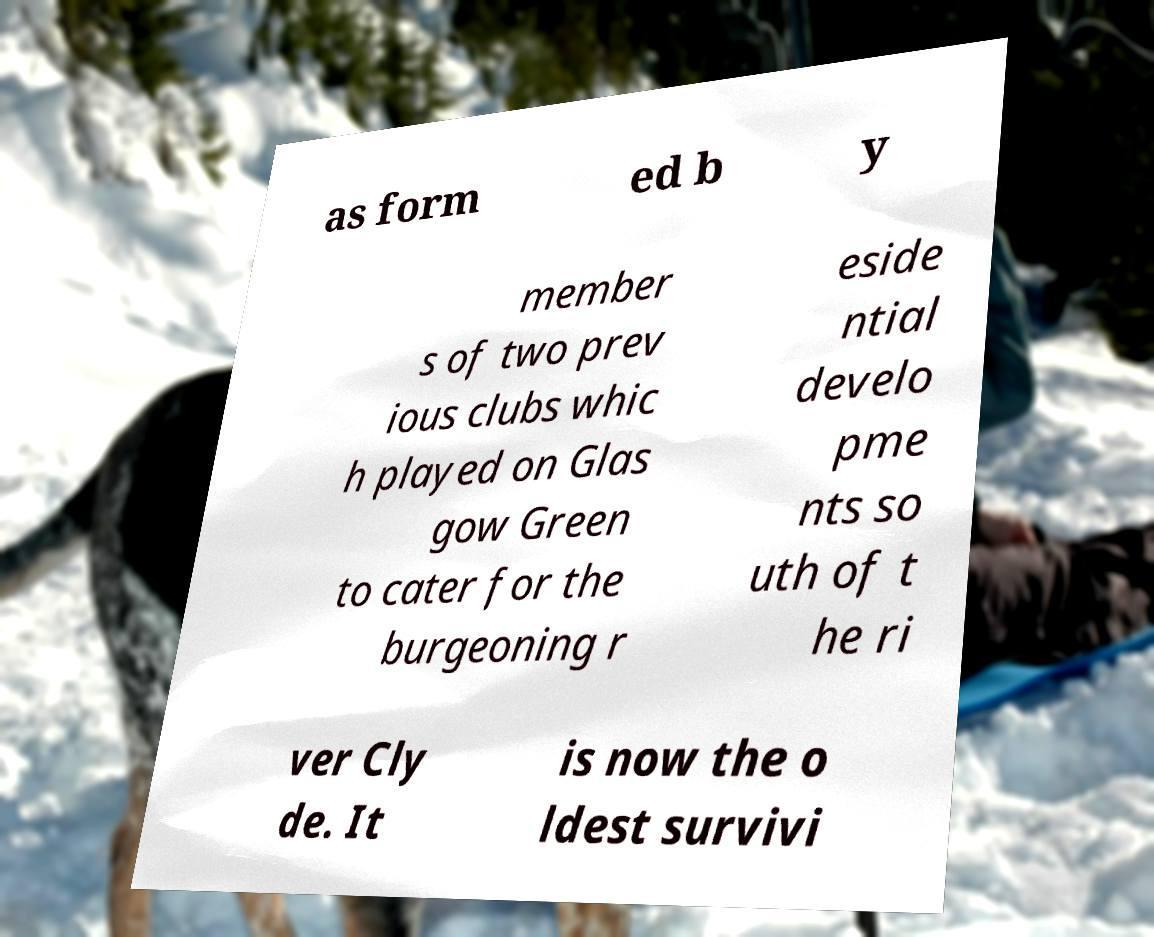For documentation purposes, I need the text within this image transcribed. Could you provide that? as form ed b y member s of two prev ious clubs whic h played on Glas gow Green to cater for the burgeoning r eside ntial develo pme nts so uth of t he ri ver Cly de. It is now the o ldest survivi 